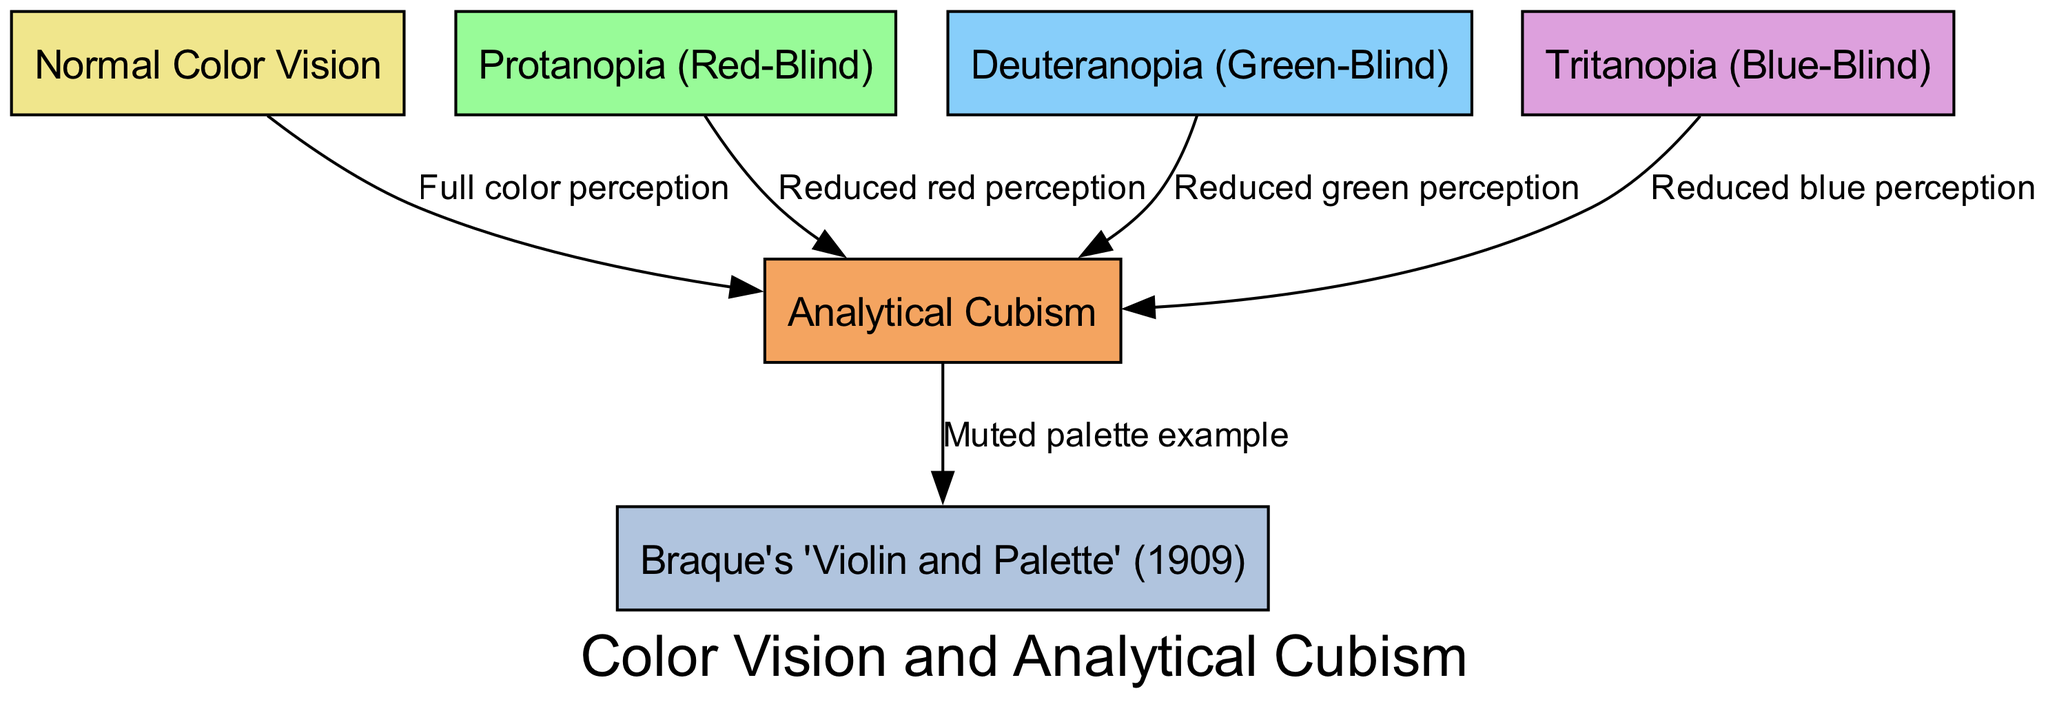What is the label of the node representing normal color vision? The diagram shows the node labeled "Normal Color Vision" clearly identified, which is the first node in the list.
Answer: Normal Color Vision How many types of color blindness are represented in the diagram? The diagram lists three types of color blindness: Protanopia, Deuteranopia, and Tritanopia, so there are a total of three nodes for color blindness.
Answer: 3 What is the relationship between normal color vision and Analytical Cubism? The edge from the "Normal Color Vision" node to the "Analytical Cubism" node indicates a relationship described as "Full color perception," showing that Analytical Cubism utilizes full color.
Answer: Full color perception What kind of vision does the edge from Protanopia to Analytical Cubism depict? The diagram shows an edge from "Protanopia" to "Analytical Cubism" labeled "Reduced red perception," indicating that this type of color blindness affects the perception of red colors.
Answer: Reduced red perception Which artwork is associated with Analytical Cubism in the diagram? The diagram indicates an edge from the "Analytical Cubism" node to the "Braque's 'Violin and Palette' (1909)" node, illustrating the connection between Analytical Cubism and this specific piece of artwork.
Answer: Braque's 'Violin and Palette' (1909) What does Tritanopia affect in the context of Analytical Cubism? The edge from "Tritanopia" to "Analytical Cubism" states "Reduced blue perception," illustrating that individuals with Tritanopia perceive blue colors less effectively when interpreting Analytical Cubism.
Answer: Reduced blue perception Which node has the least full color perception in relation to Analytical Cubism? Among all the color blindness types depicted, Protanopia has "Reduced red perception," Deuteranopia has "Reduced green perception," and Tritanopia has "Reduced blue perception." Since all reduce perception, to determine the least, we consider the specific perceptions eliminated due to their significance in color theory; all are significant, but red has a foundational role in many contexts.
Answer: Protanopia What is the commonality shared between the nodes representing the types of color blindness? All types of color blindness nodes are linked to "Analytical Cubism," indicating that despite the reduced perception, the connection exists to this art movement.
Answer: They are linked to Analytical Cubism 